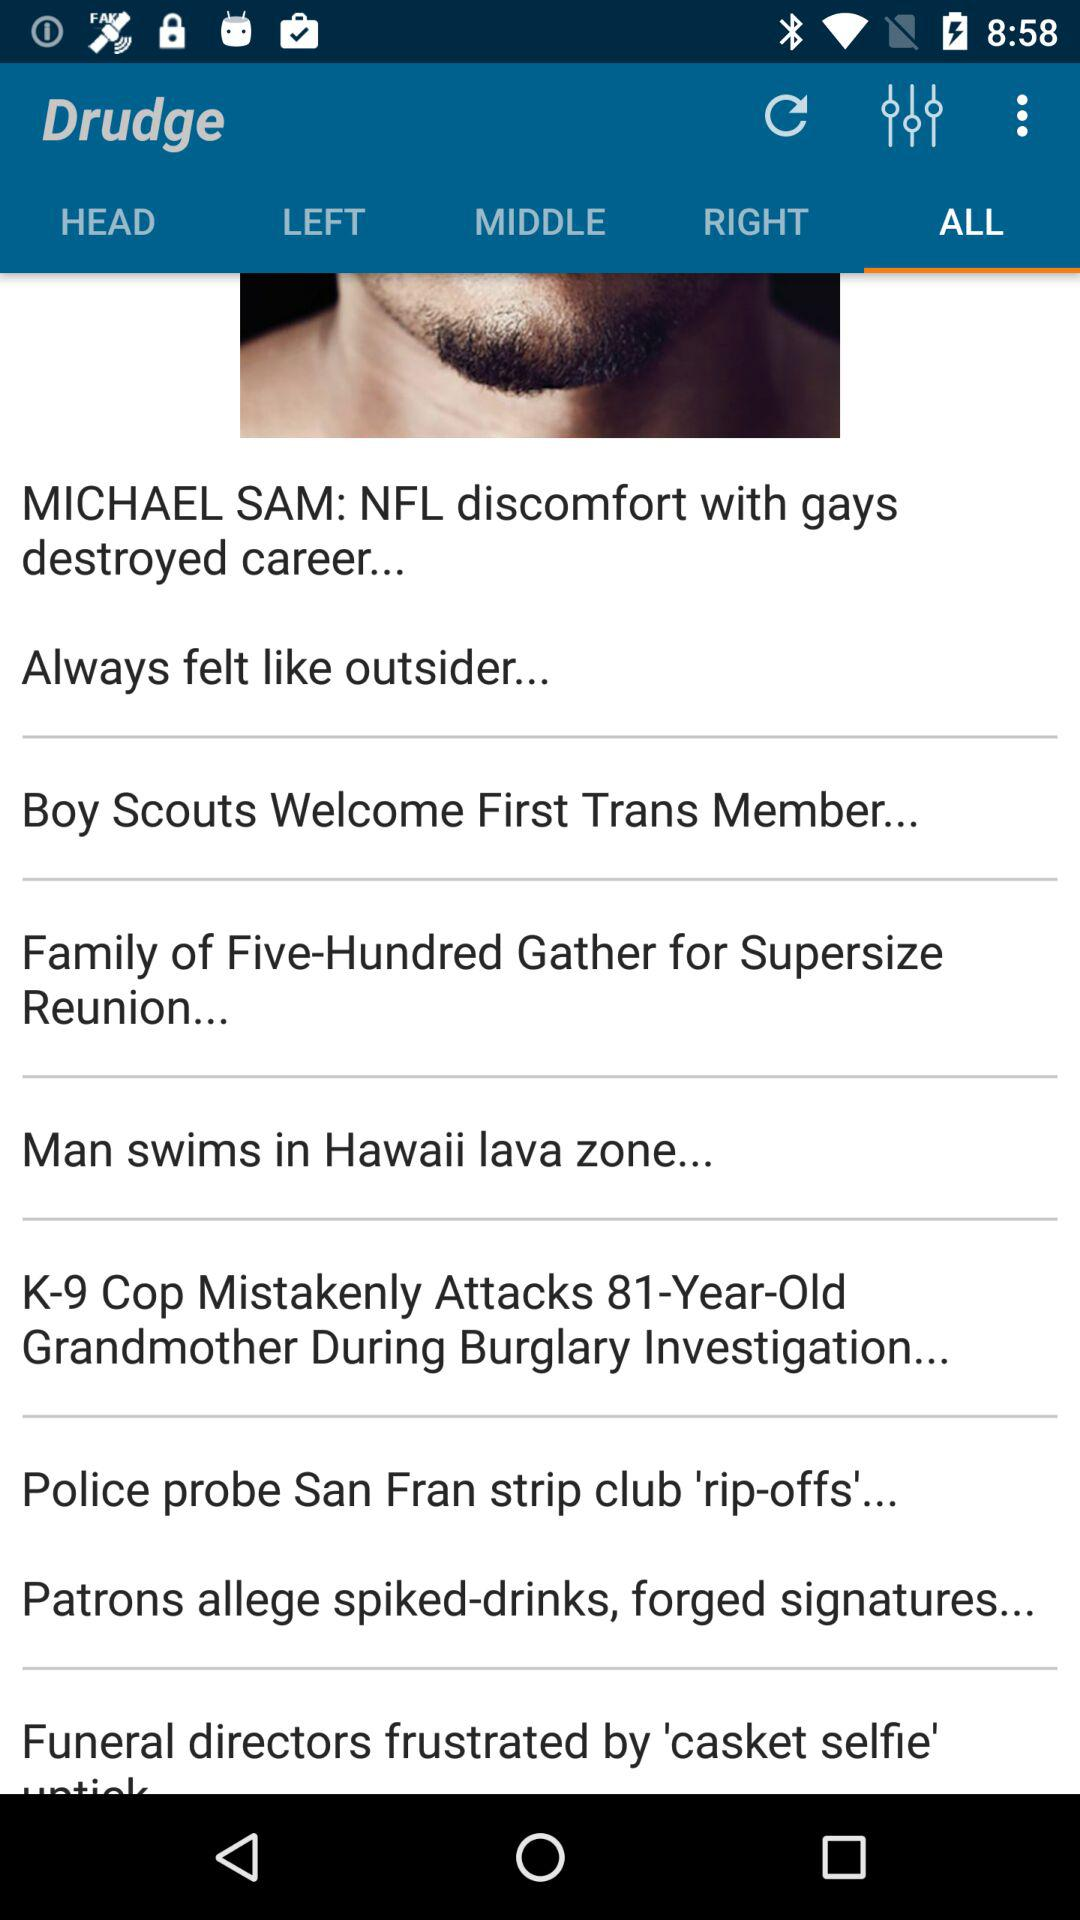What is the application name? The application name is "Drudge". 